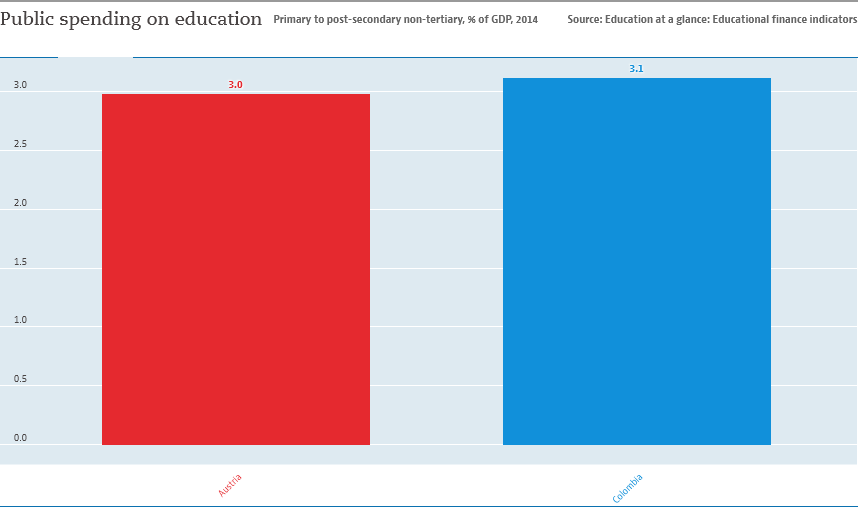List a handful of essential elements in this visual. The ratio between two bars is approximately 0.96774... The bar representing Austria is the red one. 